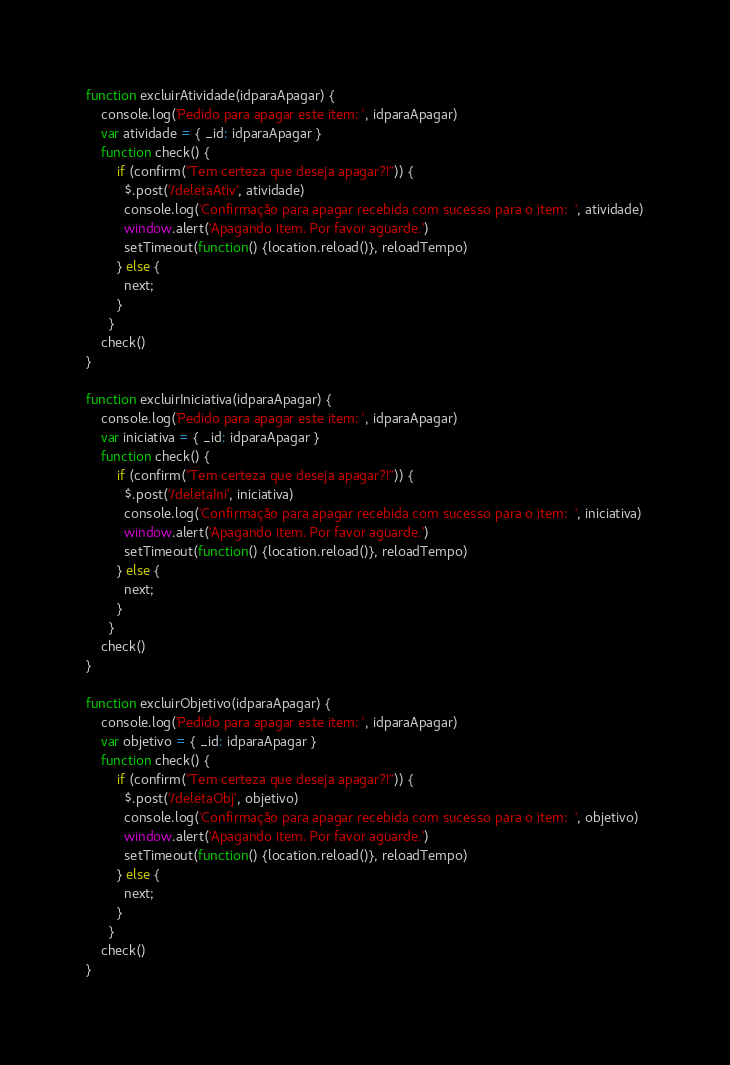Convert code to text. <code><loc_0><loc_0><loc_500><loc_500><_JavaScript_>
function excluirAtividade(idparaApagar) {
    console.log('Pedido para apagar este item: ', idparaApagar)
    var atividade = { _id: idparaApagar }
    function check() {
        if (confirm("Tem certeza que deseja apagar?!")) {
          $.post('/deletaAtiv', atividade)
          console.log('Confirmação para apagar recebida com sucesso para o item:  ', atividade)
          window.alert('Apagando item. Por favor aguarde.')
          setTimeout(function() {location.reload()}, reloadTempo)
        } else {
          next;
        }
      }
    check()
}

function excluirIniciativa(idparaApagar) {
    console.log('Pedido para apagar este item: ', idparaApagar)
    var iniciativa = { _id: idparaApagar }
    function check() {
        if (confirm("Tem certeza que deseja apagar?!")) {
          $.post('/deletaIni', iniciativa)
          console.log('Confirmação para apagar recebida com sucesso para o item:  ', iniciativa)
          window.alert('Apagando item. Por favor aguarde.')
          setTimeout(function() {location.reload()}, reloadTempo)
        } else {
          next;
        }
      }
    check()
}

function excluirObjetivo(idparaApagar) {
    console.log('Pedido para apagar este item: ', idparaApagar)
    var objetivo = { _id: idparaApagar }
    function check() {
        if (confirm("Tem certeza que deseja apagar?!")) {
          $.post('/deletaObj', objetivo)
          console.log('Confirmação para apagar recebida com sucesso para o item:  ', objetivo)
          window.alert('Apagando item. Por favor aguarde.')
          setTimeout(function() {location.reload()}, reloadTempo)
        } else {
          next;
        }
      }
    check()
}
</code> 